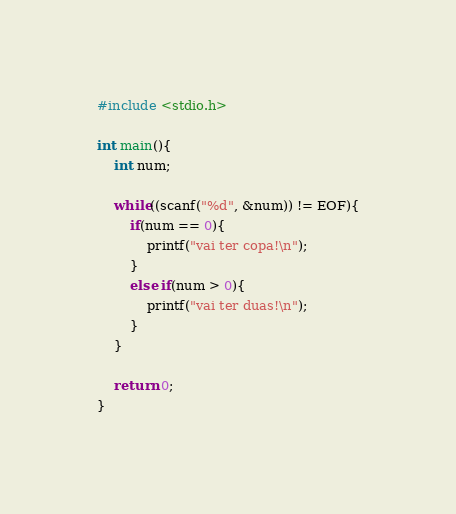Convert code to text. <code><loc_0><loc_0><loc_500><loc_500><_C_>#include <stdio.h>

int main(){
    int num;

    while((scanf("%d", &num)) != EOF){
        if(num == 0){
            printf("vai ter copa!\n");
        }
        else if(num > 0){
            printf("vai ter duas!\n");
        }
    }

    return 0;
}
</code> 